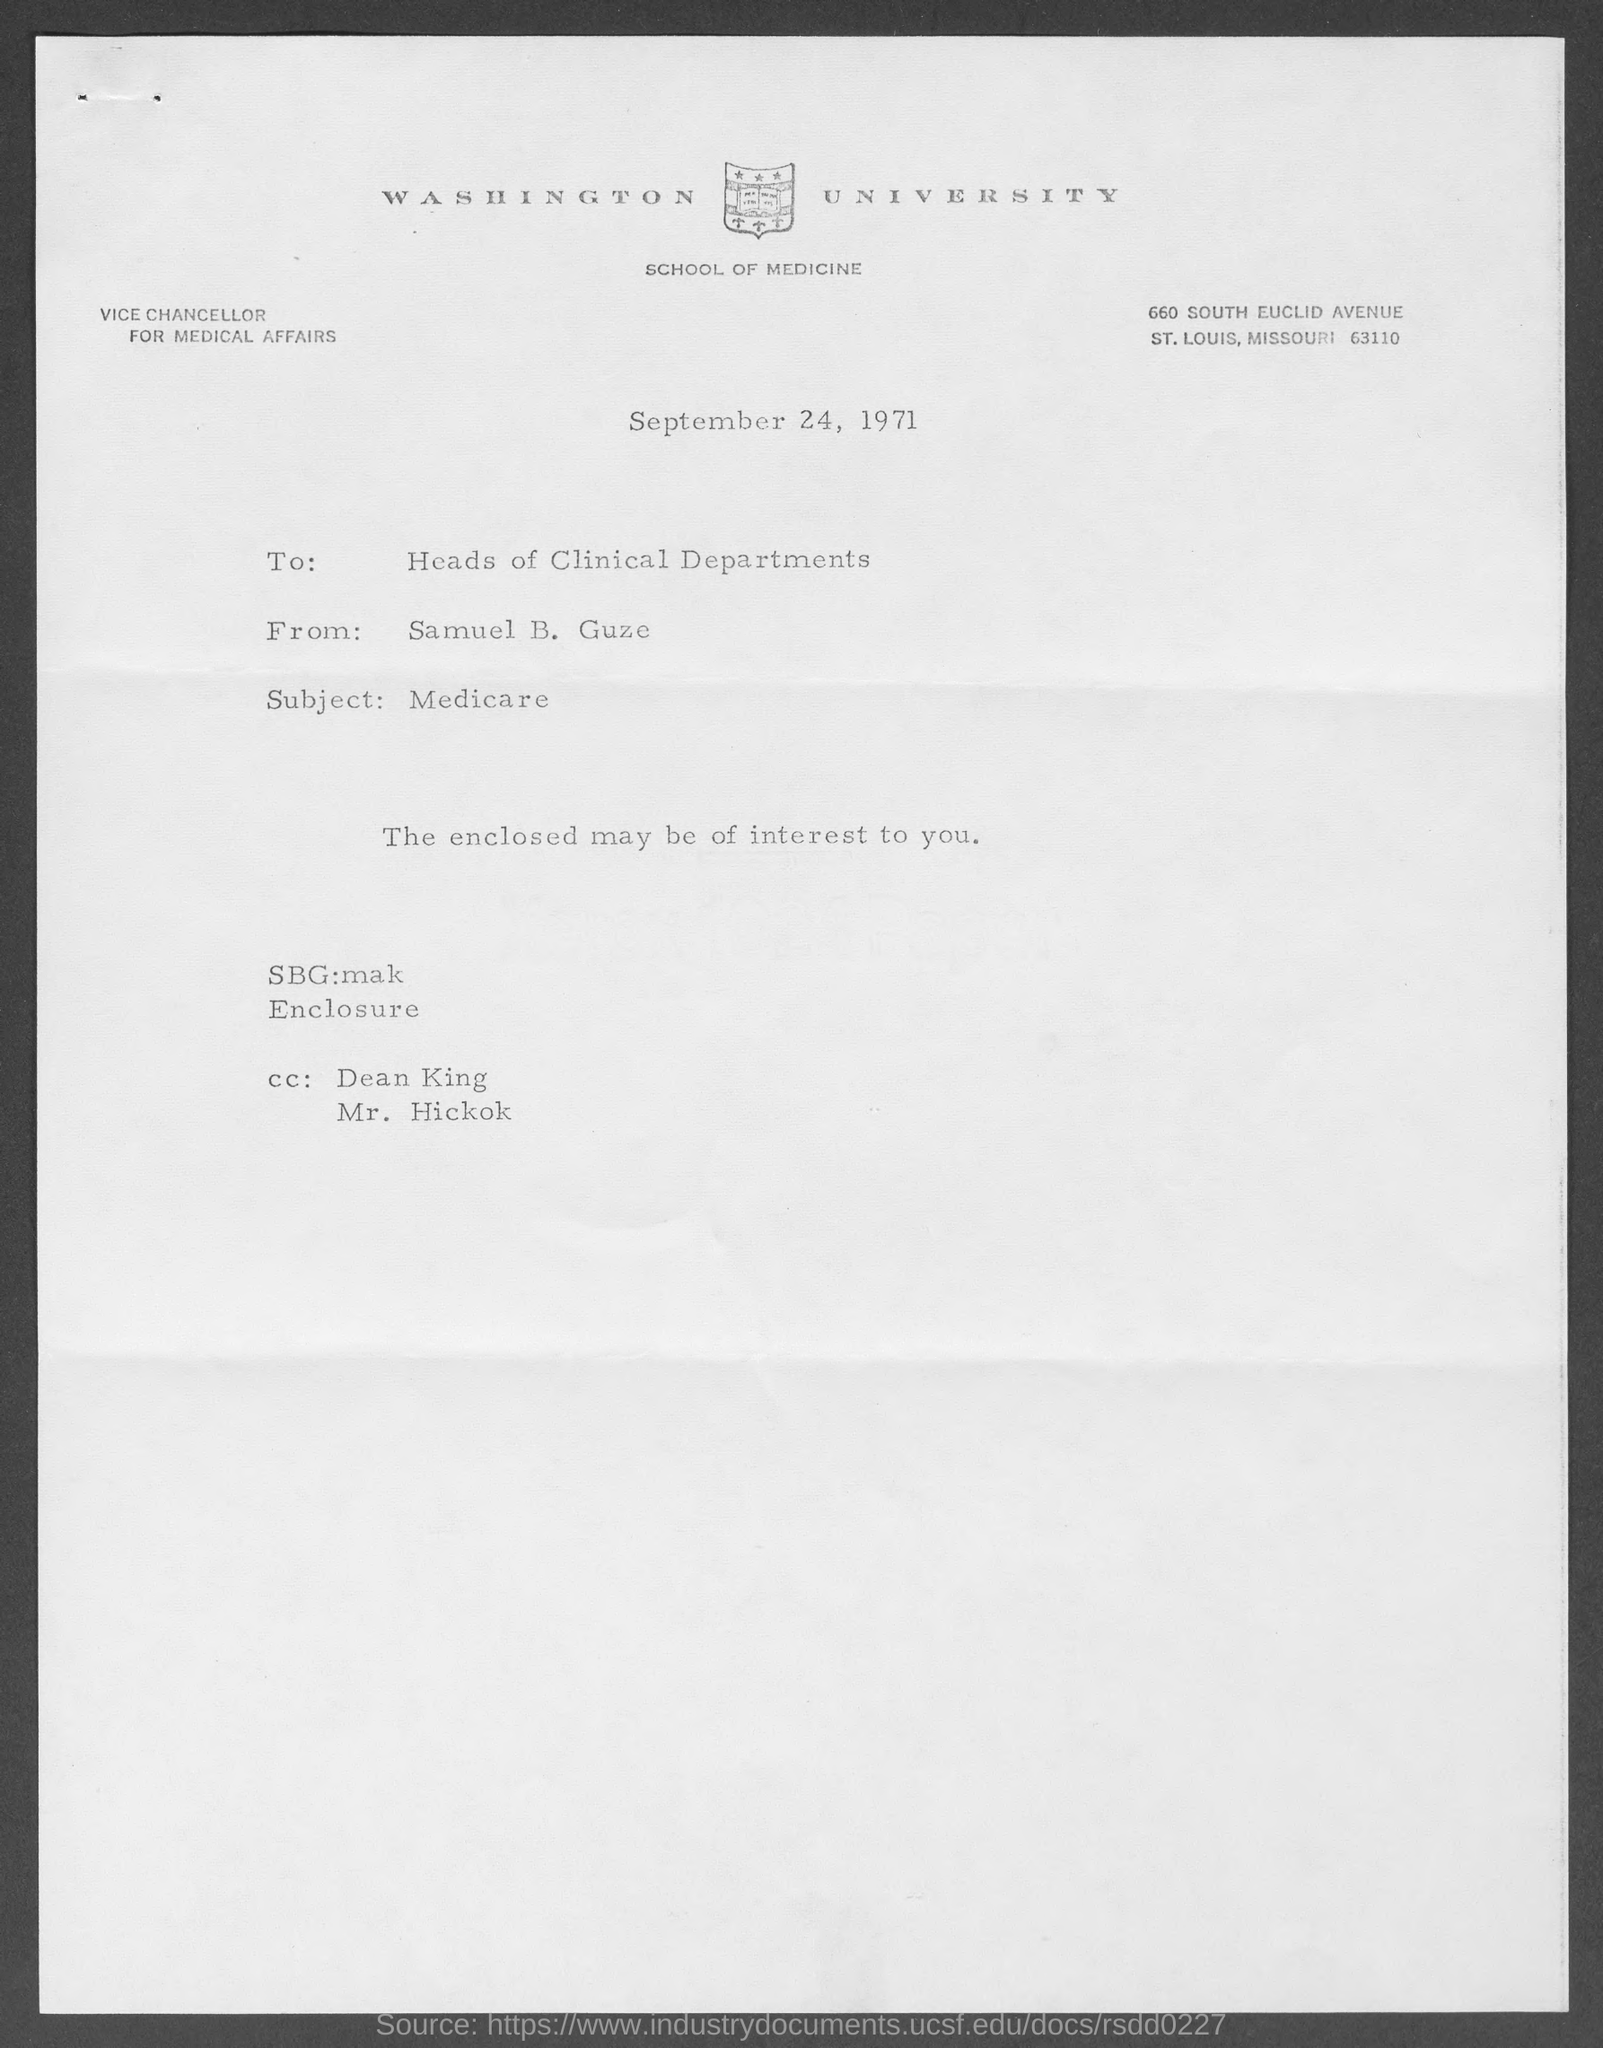Which university is mentioned in the letter head?
Your answer should be compact. WASHINGTON UNIVERSITY. What is the date mentioned in this letter?
Provide a succinct answer. September 24, 1971. Who is the sender of this letter?
Provide a succinct answer. Samuel B. Guze. What is the subject of this letter?
Provide a succinct answer. Medicare. Who is the addressee of this letter?
Your response must be concise. Heads of Clinical Departments. 